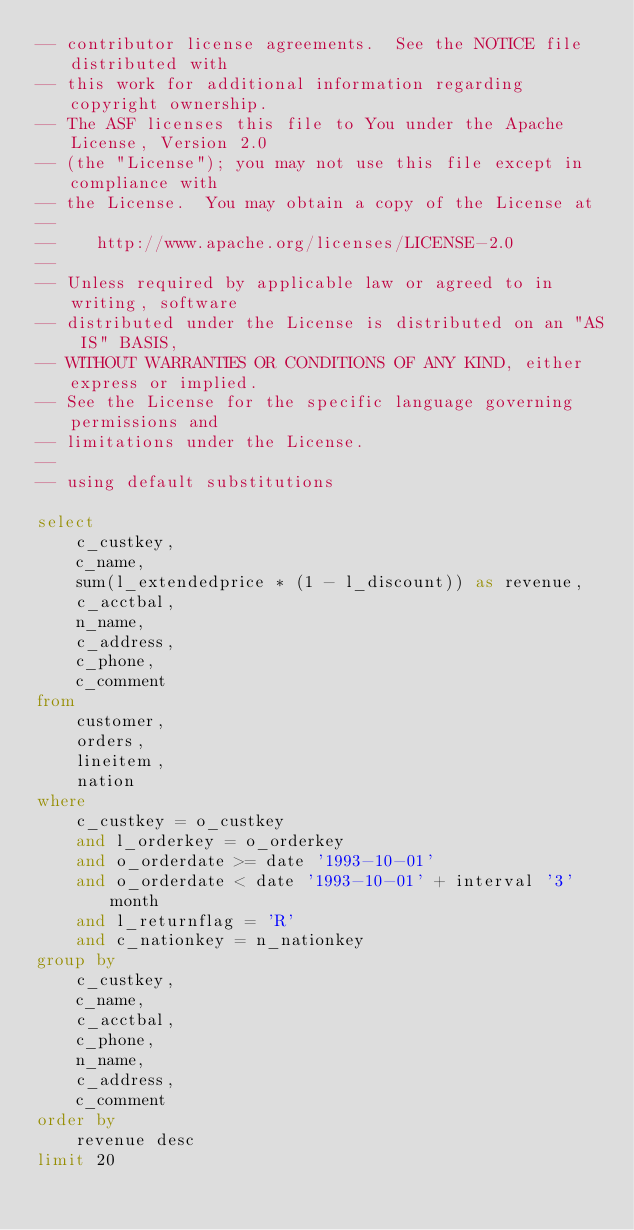Convert code to text. <code><loc_0><loc_0><loc_500><loc_500><_SQL_>-- contributor license agreements.  See the NOTICE file distributed with
-- this work for additional information regarding copyright ownership.
-- The ASF licenses this file to You under the Apache License, Version 2.0
-- (the "License"); you may not use this file except in compliance with
-- the License.  You may obtain a copy of the License at
--
--    http://www.apache.org/licenses/LICENSE-2.0
--
-- Unless required by applicable law or agreed to in writing, software
-- distributed under the License is distributed on an "AS IS" BASIS,
-- WITHOUT WARRANTIES OR CONDITIONS OF ANY KIND, either express or implied.
-- See the License for the specific language governing permissions and
-- limitations under the License.
--
-- using default substitutions

select
    c_custkey,
    c_name,
    sum(l_extendedprice * (1 - l_discount)) as revenue,
    c_acctbal,
    n_name,
    c_address,
    c_phone,
    c_comment
from
    customer,
    orders,
    lineitem,
    nation
where
    c_custkey = o_custkey
    and l_orderkey = o_orderkey
    and o_orderdate >= date '1993-10-01'
    and o_orderdate < date '1993-10-01' + interval '3' month
    and l_returnflag = 'R'
    and c_nationkey = n_nationkey
group by
    c_custkey,
    c_name,
    c_acctbal,
    c_phone,
    n_name,
    c_address,
    c_comment
order by
    revenue desc
limit 20
</code> 